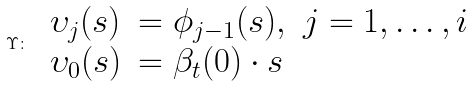Convert formula to latex. <formula><loc_0><loc_0><loc_500><loc_500>\Upsilon \colon \ \begin{array} { l l } \upsilon _ { j } ( s ) & = \phi _ { j - 1 } ( s ) , \ j = 1 , \dots , i \\ \upsilon _ { 0 } ( s ) & = \beta _ { t } ( 0 ) \cdot s \end{array}</formula> 